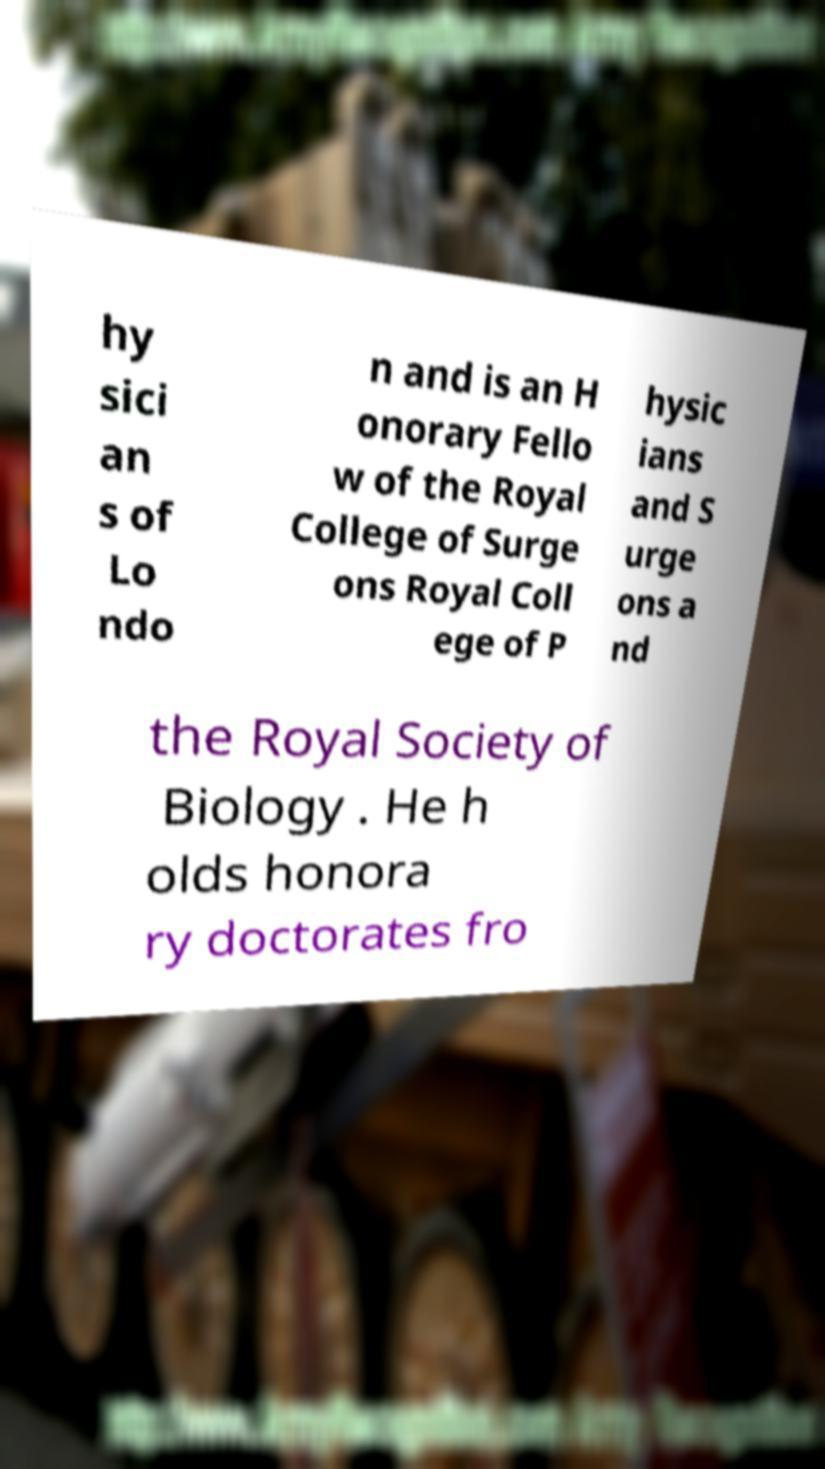For documentation purposes, I need the text within this image transcribed. Could you provide that? hy sici an s of Lo ndo n and is an H onorary Fello w of the Royal College of Surge ons Royal Coll ege of P hysic ians and S urge ons a nd the Royal Society of Biology . He h olds honora ry doctorates fro 